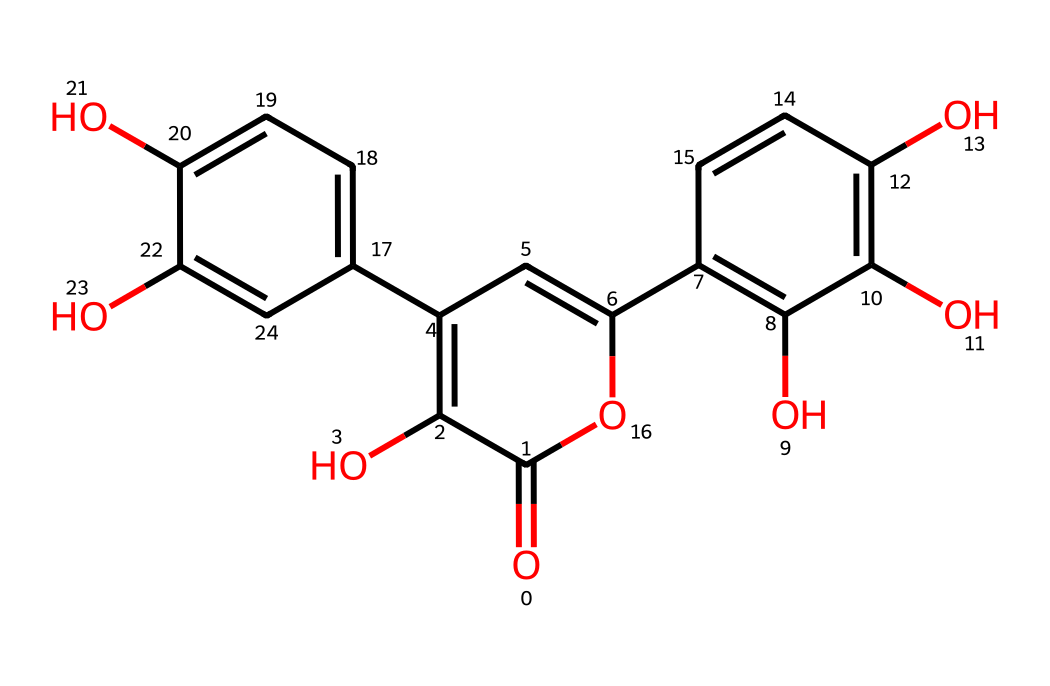how many hydroxyl groups are present in quercetin? By analyzing the chemical structure, we can identify the functional groups present. Quercetin contains multiple hydroxyl (–OH) groups, which are essential for its chemical properties. Counting all the visible hydroxyl groups in the structure results in a total of 5.
Answer: 5 what is the molecular formula of quercetin? The molecular formula can be deduced from the structure by counting the different types of atoms. From the structure, we can tally 15 carbons (C), 10 hydrogens (H), and 7 oxygens (O), leading us to the molecular formula C15H10O7.
Answer: C15H10O7 which functional groups characterize quercetin? Observing the structure, we notice it features hydroxyl groups (–OH) and a ketone group (C=O). These functional groups play a vital role in the chemical behavior of quercetin, making it a flavonoid.
Answer: hydroxyl and ketone what is the type of bond that connects the carbon atoms in quercetin? By visual inspection of the chemical structure, we can determine that the majority of carbon atoms are connected by single bonds (–C–) and some by double bonds (–C=C–). Thus, it incorporates both single and double carbon-carbon bonds, characteristic of phenolic compounds.
Answer: single and double how many rings are present in the quercetin structure? Analyzing the structure shows that there are three distinct rings formed by the arrangement of carbon atoms in quercetin. Each ring contributes to the overall stability and characteristic properties of the flavonoid.
Answer: 3 what category of phytochemicals does quercetin belong to? Quercetin's structure fits the definition of flavonoids, which are a class of polyphenolic compounds. This categorization is based on its characteristic structures that include multiple hydroxyl groups and aromatic rings.
Answer: flavonoid 